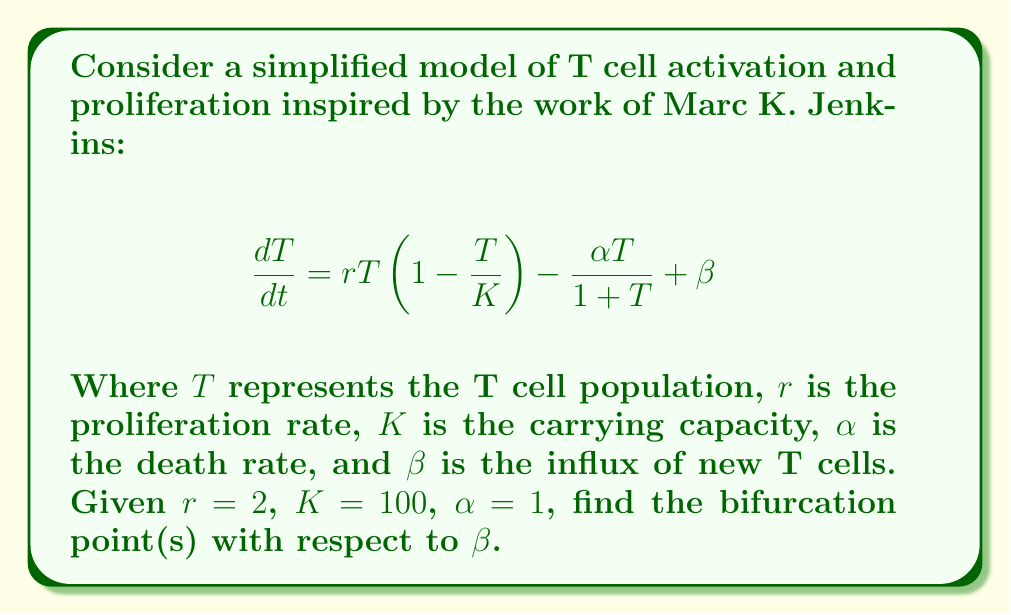Can you answer this question? To find the bifurcation points, we need to follow these steps:

1) First, find the equilibrium points by setting $\frac{dT}{dt} = 0$:

   $$0 = 2T(1-\frac{T}{100}) - \frac{T}{1+T} + \beta$$

2) Rearrange the equation:

   $$\frac{T}{1+T} - 2T(1-\frac{T}{100}) = \beta$$

3) Multiply both sides by $(1+T)$:

   $$T - 2T(1-\frac{T}{100})(1+T) = \beta(1+T)$$

4) Expand:

   $$T - 2T - 2T^2 + \frac{2T^2}{100} + \frac{2T^3}{100} = \beta + \beta T$$

5) Collect terms:

   $$-T - 2T^2 + \frac{2T^2}{100} + \frac{2T^3}{100} = \beta + \beta T$$

6) Rearrange:

   $$\frac{2T^3}{100} + (\frac{2}{100}-2)T^2 + (-1-\beta)T - \beta = 0$$

7) For a bifurcation to occur, this cubic equation should have a double root. This happens when its discriminant is zero. The discriminant of a cubic equation $ax^3 + bx^2 + cx + d = 0$ is given by:

   $$\Delta = 18abcd - 4b^3d + b^2c^2 - 4ac^3 - 27a^2d^2$$

8) In our case:
   $a = \frac{2}{100}$
   $b = \frac{2}{100}-2 = -1.98$
   $c = -1-\beta$
   $d = -\beta$

9) Substitute these into the discriminant equation and set it to zero:

   $$18(\frac{2}{100})(-1.98)(-1-\beta)(-\beta) - 4(-1.98)^3(-\beta) + (-1.98)^2(-1-\beta)^2 - 4(\frac{2}{100})(-1-\beta)^3 - 27(\frac{2}{100})^2(-\beta)^2 = 0$$

10) This equation in $\beta$ is quite complex. Solving it numerically gives two solutions: $\beta \approx 0.2846$ and $\beta \approx 49.7154$.

These are the bifurcation points of the system with respect to $\beta$.
Answer: $\beta \approx 0.2846$ and $\beta \approx 49.7154$ 